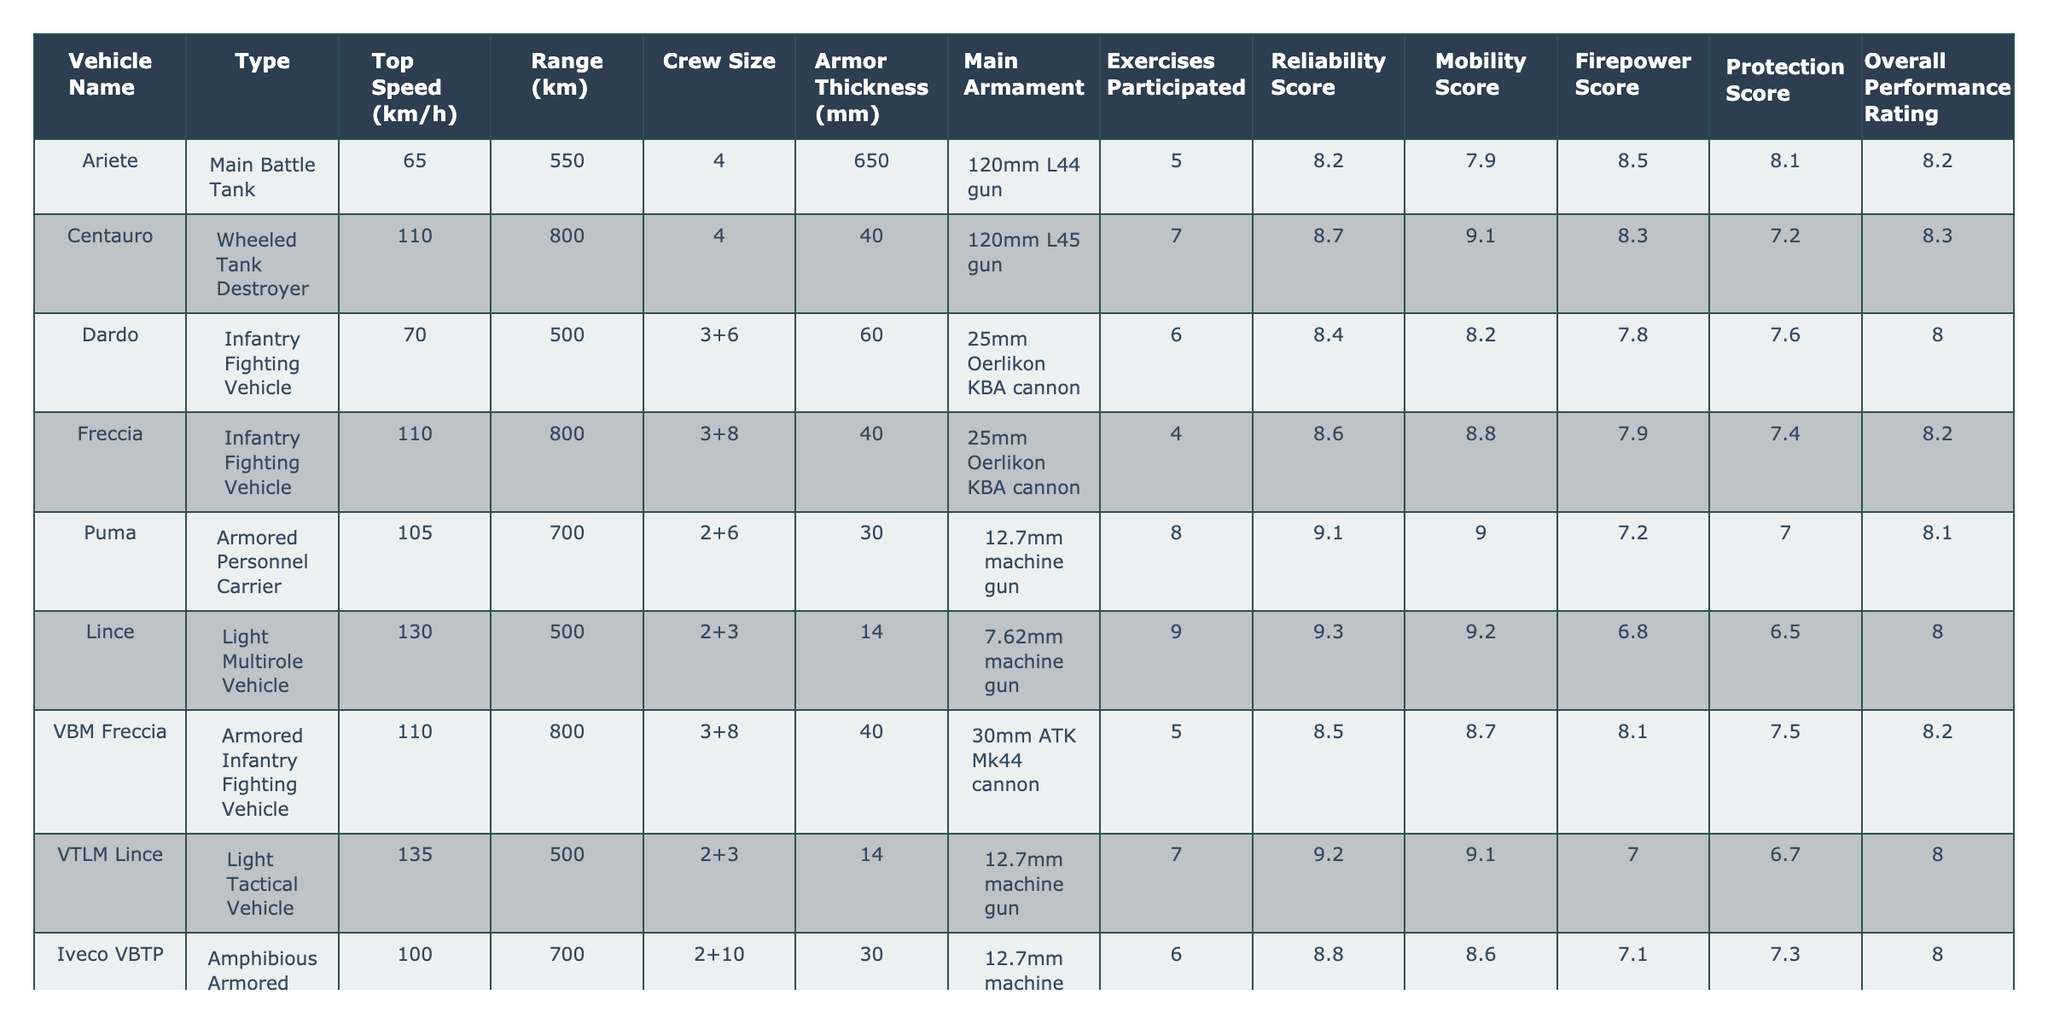What is the top speed of the Ariete tank? The table shows that the top speed of the Ariete tank is 65 km/h.
Answer: 65 km/h How many exercises did the Centauro participate in? According to the table, the Centauro participated in 7 exercises.
Answer: 7 What is the armor thickness of the Puma? The table indicates that the armor thickness of the Puma is 30 mm.
Answer: 30 mm Which vehicle has the highest mobility score? By comparing the mobility scores, the Lince has the highest score at 9.3.
Answer: Lince What is the overall performance rating for the Dardo? The table states that the overall performance rating for the Dardo is 8.0.
Answer: 8.0 Calculate the average range of the vehicles listed. The total range is 550 + 800 + 500 + 800 + 700 + 500 + 800 + 500 + 700 = 5350 km. There are 9 vehicles, so the average range is 5350 / 9 ≈ 594.44 km.
Answer: 594.44 km Is the Freccia's firepower score higher than 8? The firepower score for the Freccia is 7.9, which is not higher than 8.
Answer: No Which vehicle has the lowest crew size? The Puma and the Iveco VBTP both have the lowest crew size of 8 (2+6).
Answer: Puma, Iveco VBTP If you compare the top speeds, how much faster is the VTLM Lince than the Iveco LMV? The top speed of VTLM Lince is 135 km/h and the Iveco LMV is 130 km/h. The difference is 135 - 130 = 5 km/h.
Answer: 5 km/h Which vehicle has the best reliability score? The table shows the Puma has the best reliability score of 9.1.
Answer: Puma What is the average armor thickness for all vehicles? The total armor thickness is 650 + 40 + 60 + 40 + 30 + 14 + 40 + 14 + 30 = 1018 mm. Dividing by 9 vehicles gives an average of 1018 / 9 ≈ 113.11 mm.
Answer: 113.11 mm Is the overall performance rating of the Dardo greater than that of the Ariete? The overall performance rating for Dardo is 8.0 and for Ariete is 8.2; therefore, it is not greater.
Answer: No Which vehicle participated in the most exercises? The vehicle that participated in the most exercises is the Puma with 8.
Answer: Puma If we consider the mobility scores, which vehicle's score is exactly 8.0? The Dardo, VBM Freccia, and Iveco VBTP all have a mobility score of exactly 8.0.
Answer: Dardo, VBM Freccia, Iveco VBTP What is the total number of crew members across all vehicles? Summing the crew sizes: 4 + 4 + 9 + 11 + 8 + 5 + 11 + 5 + 10 = 67 crew members total.
Answer: 67 crew members 